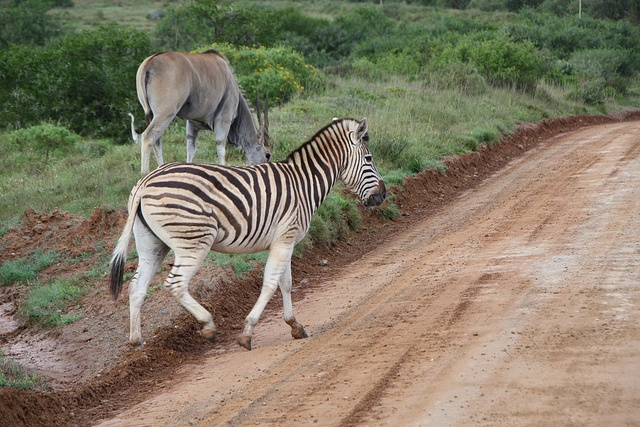Describe the objects in this image and their specific colors. I can see zebra in darkgreen, darkgray, lightgray, black, and gray tones, horse in darkgreen, darkgray, and gray tones, and bird in darkgreen, darkgray, lightgray, gray, and lightblue tones in this image. 